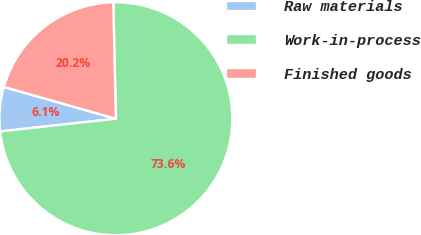Convert chart. <chart><loc_0><loc_0><loc_500><loc_500><pie_chart><fcel>Raw materials<fcel>Work-in-process<fcel>Finished goods<nl><fcel>6.14%<fcel>73.62%<fcel>20.24%<nl></chart> 